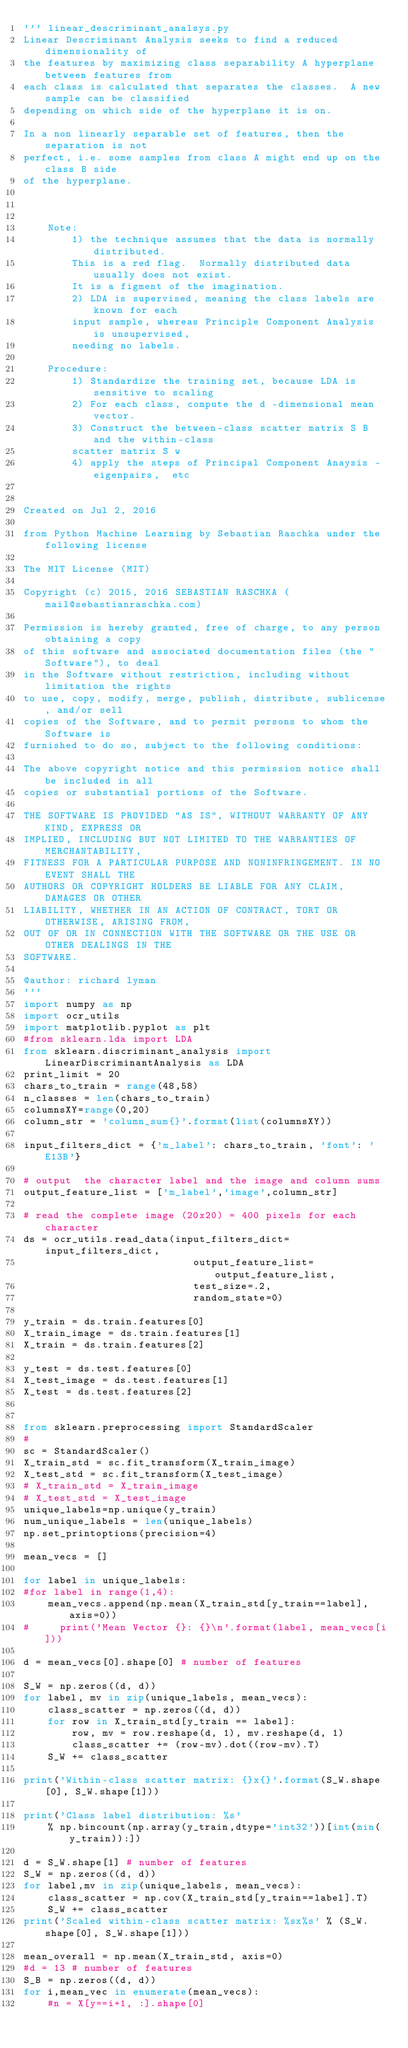<code> <loc_0><loc_0><loc_500><loc_500><_Python_>''' linear_descriminant_analsys.py 
Linear Descriminant Analysis seeks to find a reduced dimensionality of 
the features by maximizing class separability A hyperplane between features from 
each class is calculated that separates the classes.  A new sample can be classified 
depending on which side of the hyperplane it is on.

In a non linearly separable set of features, then the separation is not 
perfect, i.e. some samples from class A might end up on the class B side
of the hyperplane.



    Note:  
        1) the technique assumes that the data is normally distributed.
        This is a red flag.  Normally distributed data usually does not exist.
        It is a figment of the imagination.
        2) LDA is supervised, meaning the class labels are known for each
        input sample, whereas Principle Component Analysis is unsupervised, 
        needing no labels.
        
    Procedure:
        1) Standardize the training set, because LDA is sensitive to scaling
        2) For each class, compute the d -dimensional mean vector.
        3) Construct the between-class scatter matrix S B and the within-class 
        scatter matrix S w
        4) apply the steps of Principal Component Anaysis - eigenpairs,  etc
        
        
Created on Jul 2, 2016

from Python Machine Learning by Sebastian Raschka under the following license

The MIT License (MIT)

Copyright (c) 2015, 2016 SEBASTIAN RASCHKA (mail@sebastianraschka.com)

Permission is hereby granted, free of charge, to any person obtaining a copy
of this software and associated documentation files (the "Software"), to deal
in the Software without restriction, including without limitation the rights
to use, copy, modify, merge, publish, distribute, sublicense, and/or sell
copies of the Software, and to permit persons to whom the Software is
furnished to do so, subject to the following conditions:

The above copyright notice and this permission notice shall be included in all
copies or substantial portions of the Software.

THE SOFTWARE IS PROVIDED "AS IS", WITHOUT WARRANTY OF ANY KIND, EXPRESS OR
IMPLIED, INCLUDING BUT NOT LIMITED TO THE WARRANTIES OF MERCHANTABILITY,
FITNESS FOR A PARTICULAR PURPOSE AND NONINFRINGEMENT. IN NO EVENT SHALL THE
AUTHORS OR COPYRIGHT HOLDERS BE LIABLE FOR ANY CLAIM, DAMAGES OR OTHER
LIABILITY, WHETHER IN AN ACTION OF CONTRACT, TORT OR OTHERWISE, ARISING FROM,
OUT OF OR IN CONNECTION WITH THE SOFTWARE OR THE USE OR OTHER DEALINGS IN THE
SOFTWARE.

@author: richard lyman
'''
import numpy as np
import ocr_utils
import matplotlib.pyplot as plt
#from sklearn.lda import LDA
from sklearn.discriminant_analysis import  LinearDiscriminantAnalysis as LDA   
print_limit = 20
chars_to_train = range(48,58)
n_classes = len(chars_to_train)
columnsXY=range(0,20)
column_str = 'column_sum{}'.format(list(columnsXY))

input_filters_dict = {'m_label': chars_to_train, 'font': 'E13B'}

# output  the character label and the image and column sums
output_feature_list = ['m_label','image',column_str] 

# read the complete image (20x20) = 400 pixels for each character
ds = ocr_utils.read_data(input_filters_dict=input_filters_dict, 
                            output_feature_list=output_feature_list, 
                            test_size=.2,
                            random_state=0)
   
y_train = ds.train.features[0]
X_train_image = ds.train.features[1]
X_train = ds.train.features[2]

y_test = ds.test.features[0]
X_test_image = ds.test.features[1]
X_test = ds.test.features[2]


from sklearn.preprocessing import StandardScaler
# 
sc = StandardScaler()
X_train_std = sc.fit_transform(X_train_image)
X_test_std = sc.fit_transform(X_test_image)
# X_train_std = X_train_image
# X_test_std = X_test_image
unique_labels=np.unique(y_train)
num_unique_labels = len(unique_labels)
np.set_printoptions(precision=4)

mean_vecs = []

for label in unique_labels:
#for label in range(1,4):
    mean_vecs.append(np.mean(X_train_std[y_train==label], axis=0))
#     print('Mean Vector {}: {}\n'.format(label, mean_vecs[i]))

d = mean_vecs[0].shape[0] # number of features

S_W = np.zeros((d, d))
for label, mv in zip(unique_labels, mean_vecs):
    class_scatter = np.zeros((d, d))
    for row in X_train_std[y_train == label]:
        row, mv = row.reshape(d, 1), mv.reshape(d, 1)
        class_scatter += (row-mv).dot((row-mv).T)
    S_W += class_scatter
   
print('Within-class scatter matrix: {}x{}'.format(S_W.shape[0], S_W.shape[1]))

print('Class label distribution: %s'
    % np.bincount(np.array(y_train,dtype='int32'))[int(min(y_train)):])

d = S_W.shape[1] # number of features
S_W = np.zeros((d, d))
for label,mv in zip(unique_labels, mean_vecs):
    class_scatter = np.cov(X_train_std[y_train==label].T)
    S_W += class_scatter
print('Scaled within-class scatter matrix: %sx%s' % (S_W.shape[0], S_W.shape[1]))

mean_overall = np.mean(X_train_std, axis=0)
#d = 13 # number of features
S_B = np.zeros((d, d))
for i,mean_vec in enumerate(mean_vecs):
    #n = X[y==i+1, :].shape[0]    </code> 